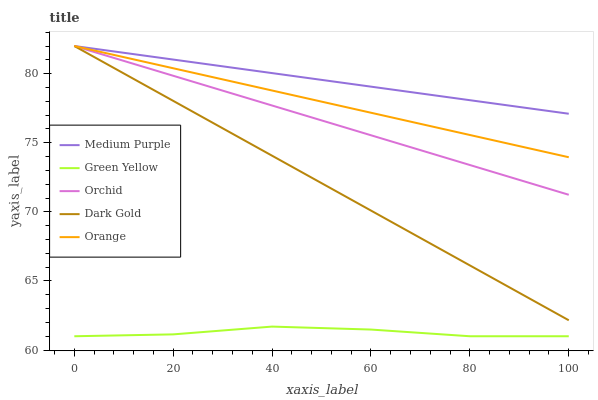Does Orange have the minimum area under the curve?
Answer yes or no. No. Does Orange have the maximum area under the curve?
Answer yes or no. No. Is Green Yellow the smoothest?
Answer yes or no. No. Is Orange the roughest?
Answer yes or no. No. Does Orange have the lowest value?
Answer yes or no. No. Does Green Yellow have the highest value?
Answer yes or no. No. Is Green Yellow less than Orchid?
Answer yes or no. Yes. Is Orchid greater than Green Yellow?
Answer yes or no. Yes. Does Green Yellow intersect Orchid?
Answer yes or no. No. 